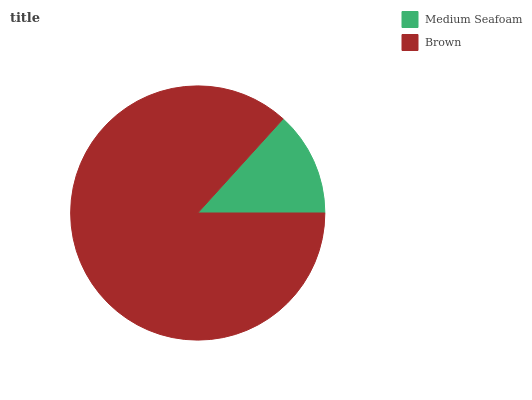Is Medium Seafoam the minimum?
Answer yes or no. Yes. Is Brown the maximum?
Answer yes or no. Yes. Is Brown the minimum?
Answer yes or no. No. Is Brown greater than Medium Seafoam?
Answer yes or no. Yes. Is Medium Seafoam less than Brown?
Answer yes or no. Yes. Is Medium Seafoam greater than Brown?
Answer yes or no. No. Is Brown less than Medium Seafoam?
Answer yes or no. No. Is Brown the high median?
Answer yes or no. Yes. Is Medium Seafoam the low median?
Answer yes or no. Yes. Is Medium Seafoam the high median?
Answer yes or no. No. Is Brown the low median?
Answer yes or no. No. 